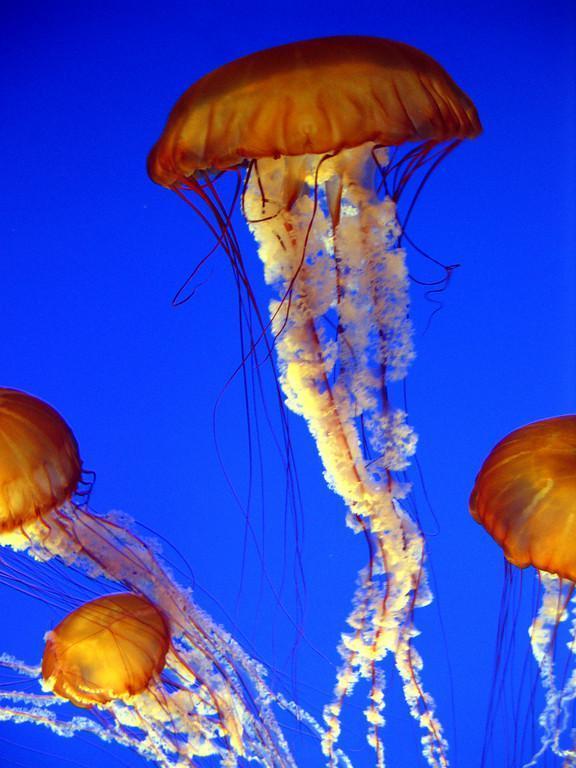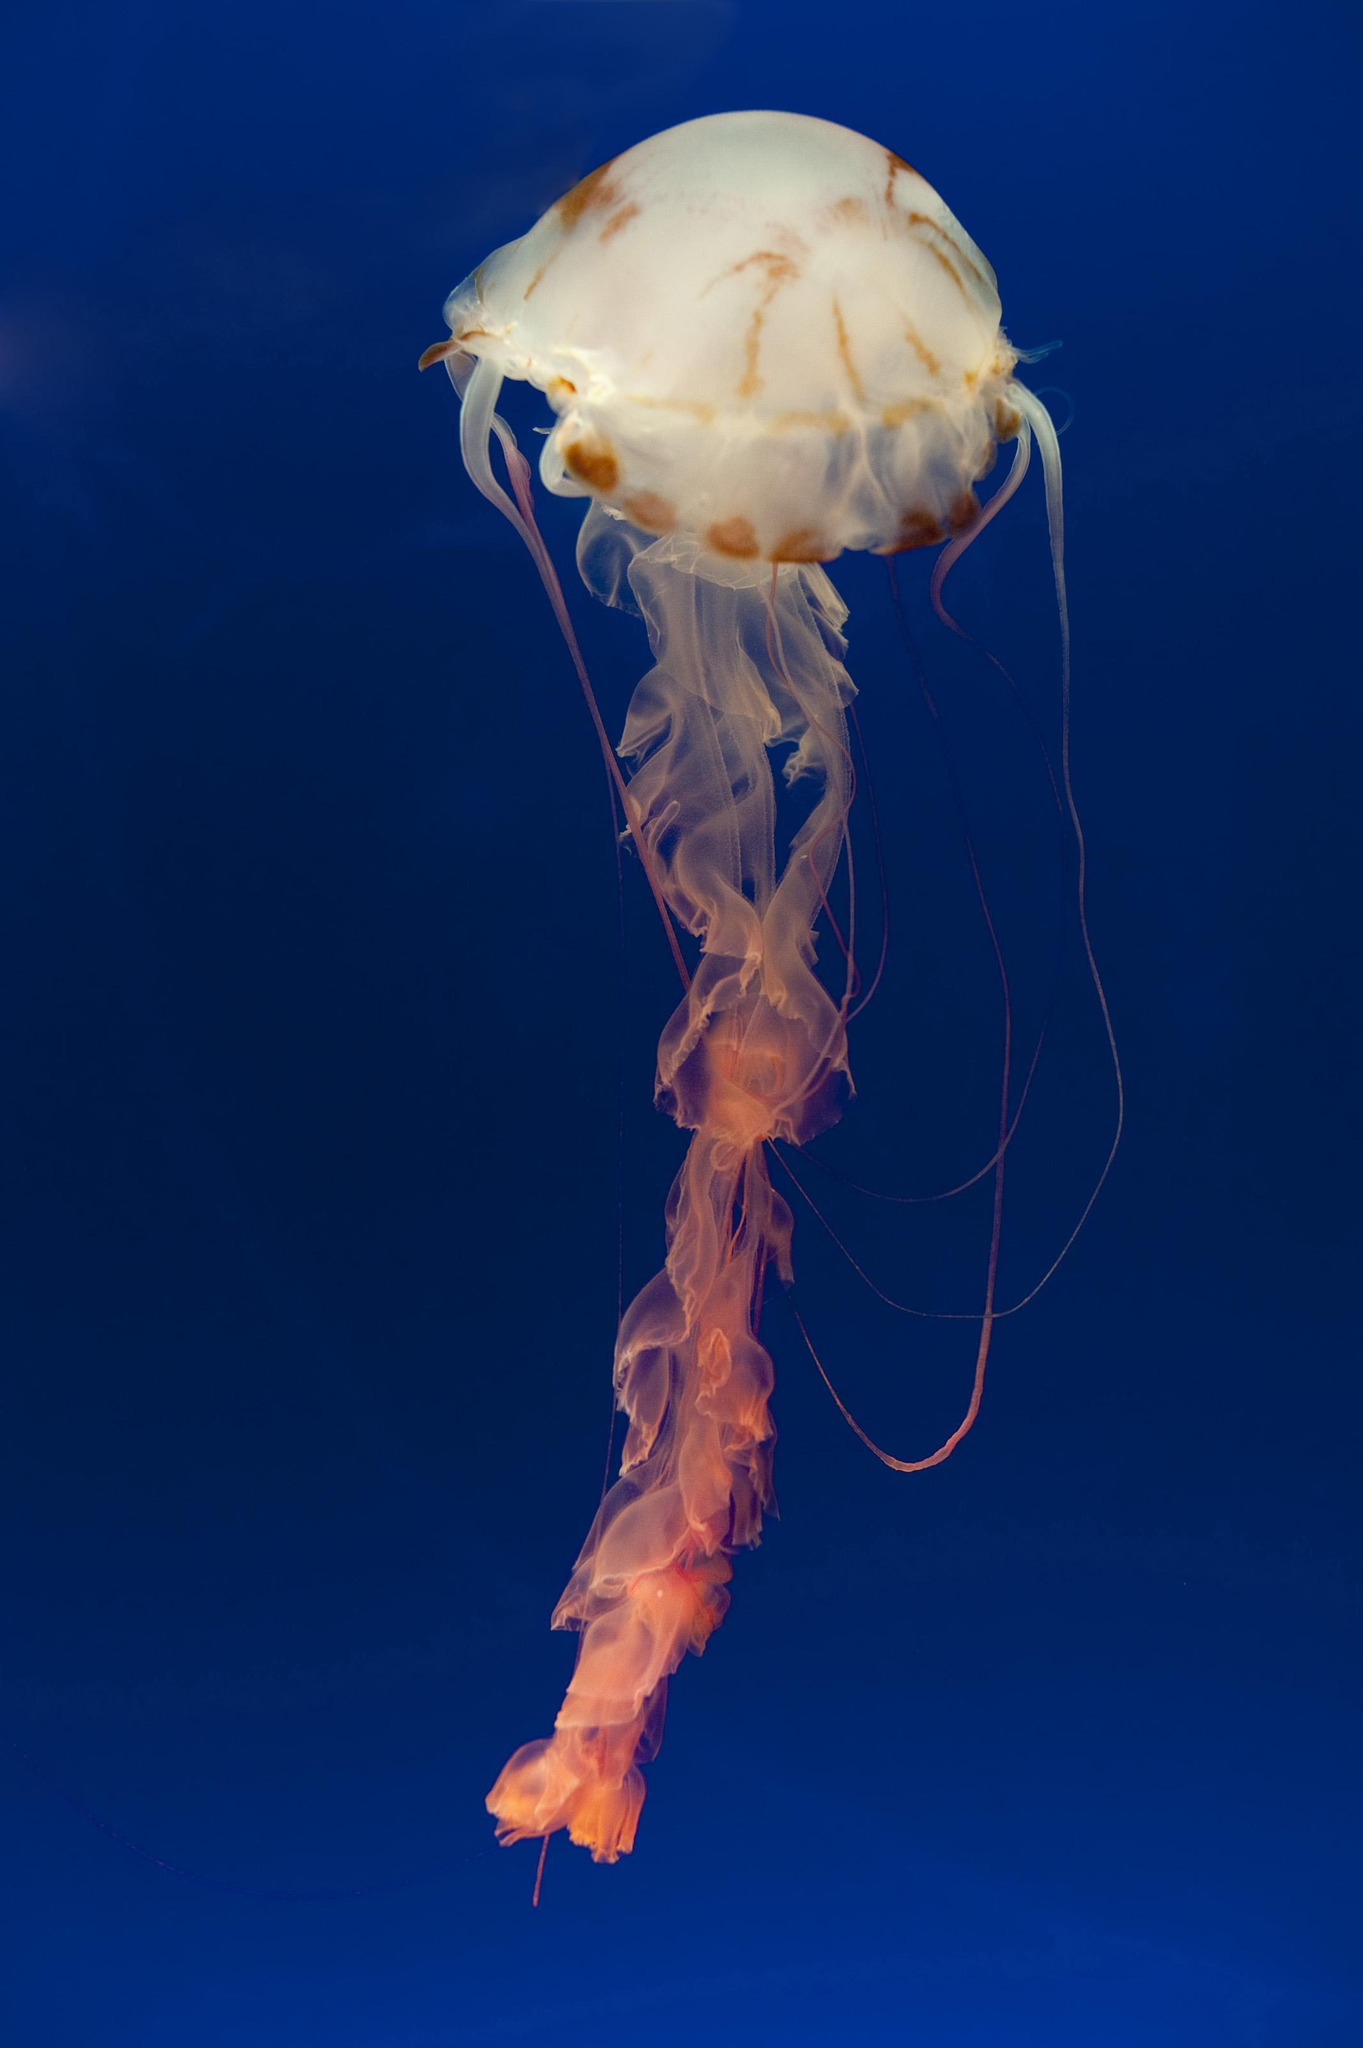The first image is the image on the left, the second image is the image on the right. Examine the images to the left and right. Is the description "The jellyfish are all swimming up with their tentacles trailing under them." accurate? Answer yes or no. Yes. The first image is the image on the left, the second image is the image on the right. Given the left and right images, does the statement "the left pic has more then three creatures" hold true? Answer yes or no. Yes. 